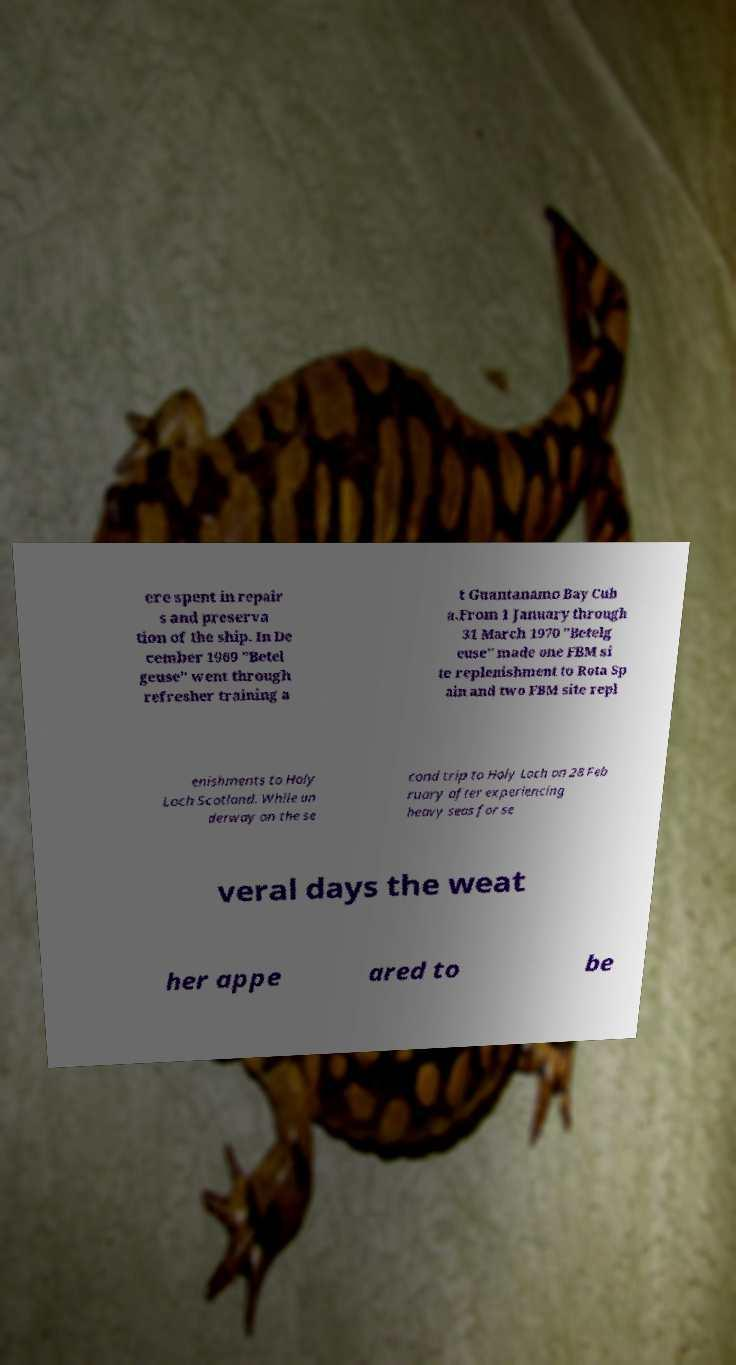Please identify and transcribe the text found in this image. ere spent in repair s and preserva tion of the ship. In De cember 1969 "Betel geuse" went through refresher training a t Guantanamo Bay Cub a.From 1 January through 31 March 1970 "Betelg euse" made one FBM si te replenishment to Rota Sp ain and two FBM site repl enishments to Holy Loch Scotland. While un derway on the se cond trip to Holy Loch on 28 Feb ruary after experiencing heavy seas for se veral days the weat her appe ared to be 